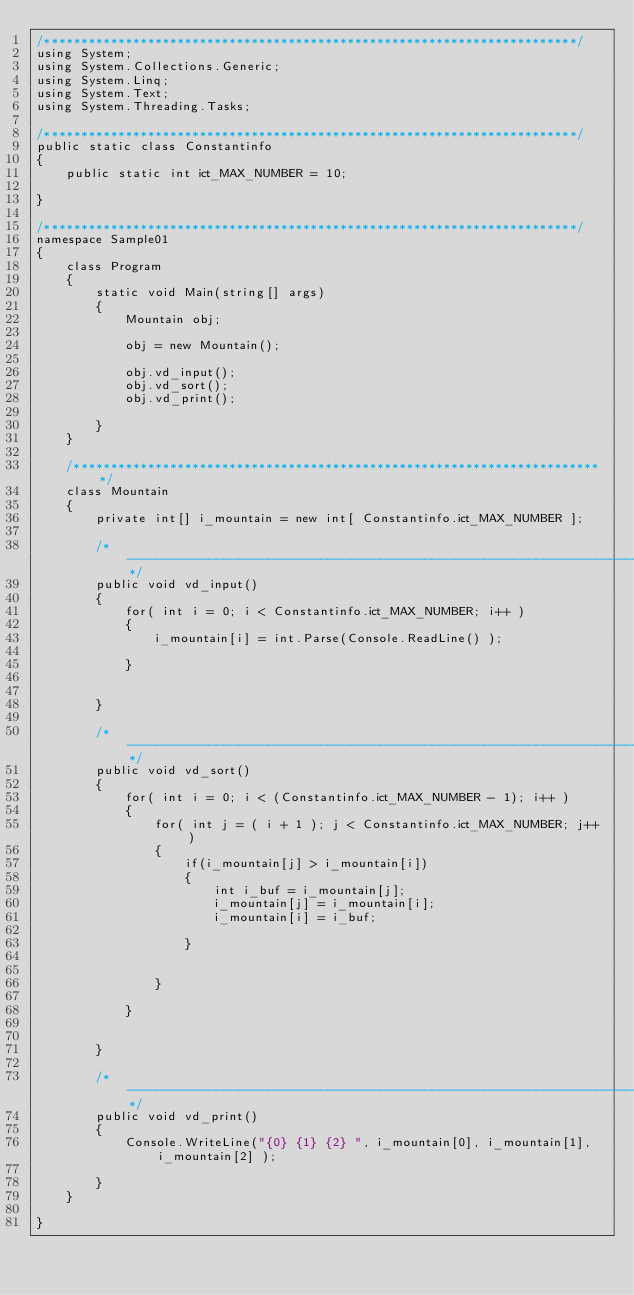<code> <loc_0><loc_0><loc_500><loc_500><_C#_>/************************************************************************/
using System;
using System.Collections.Generic;
using System.Linq;
using System.Text;
using System.Threading.Tasks;

/************************************************************************/
public static class Constantinfo
{
    public static int ict_MAX_NUMBER = 10;

}

/************************************************************************/
namespace Sample01
{
    class Program
    {
        static void Main(string[] args)
        {
            Mountain obj;

            obj = new Mountain();

            obj.vd_input();
            obj.vd_sort();
            obj.vd_print();

        }
    }

    /************************************************************************/
    class Mountain
    {
        private int[] i_mountain = new int[ Constantinfo.ict_MAX_NUMBER ];

        /*----------------------------------------------------------------------*/
        public void vd_input()
        {
            for( int i = 0; i < Constantinfo.ict_MAX_NUMBER; i++ )
            {
                i_mountain[i] = int.Parse(Console.ReadLine() );

            }


        }

        /*----------------------------------------------------------------------*/
        public void vd_sort()
        {
            for( int i = 0; i < (Constantinfo.ict_MAX_NUMBER - 1); i++ )
            {
                for( int j = ( i + 1 ); j < Constantinfo.ict_MAX_NUMBER; j++ )
                {
                    if(i_mountain[j] > i_mountain[i])
                    {
                        int i_buf = i_mountain[j];
                        i_mountain[j] = i_mountain[i];
                        i_mountain[i] = i_buf;

                    }


                }

            }


        }

        /*----------------------------------------------------------------------*/
        public void vd_print()
        {
            Console.WriteLine("{0} {1} {2} ", i_mountain[0], i_mountain[1], i_mountain[2] );

        }
    }

}</code> 